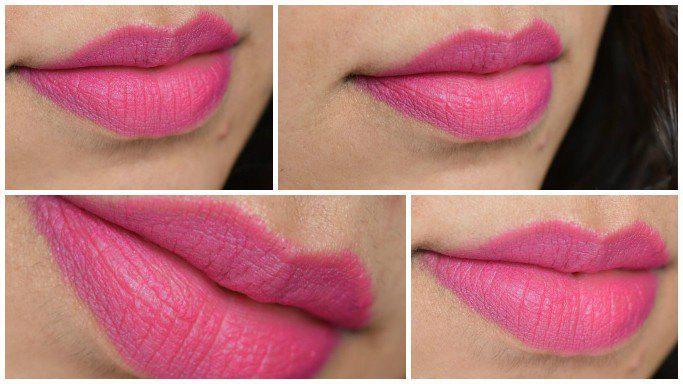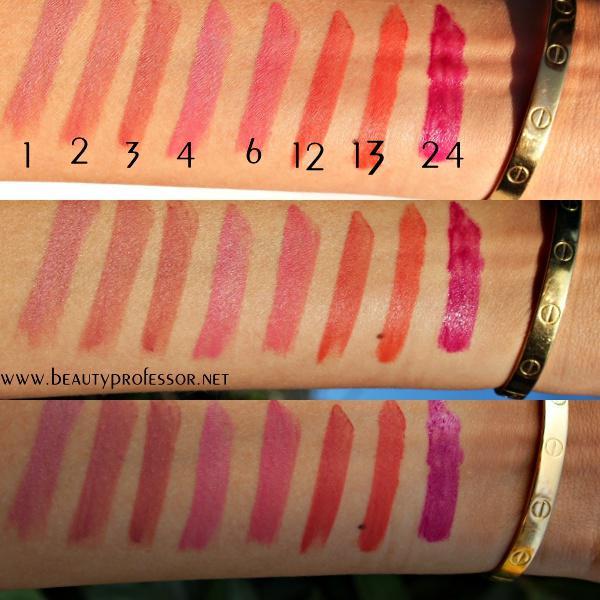The first image is the image on the left, the second image is the image on the right. Examine the images to the left and right. Is the description "One of the images shows different shades of lipstick on human arm." accurate? Answer yes or no. Yes. The first image is the image on the left, the second image is the image on the right. Evaluate the accuracy of this statement regarding the images: "An image shows smears of lipstick across at least one inner arm.". Is it true? Answer yes or no. Yes. 